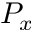<formula> <loc_0><loc_0><loc_500><loc_500>P _ { x }</formula> 